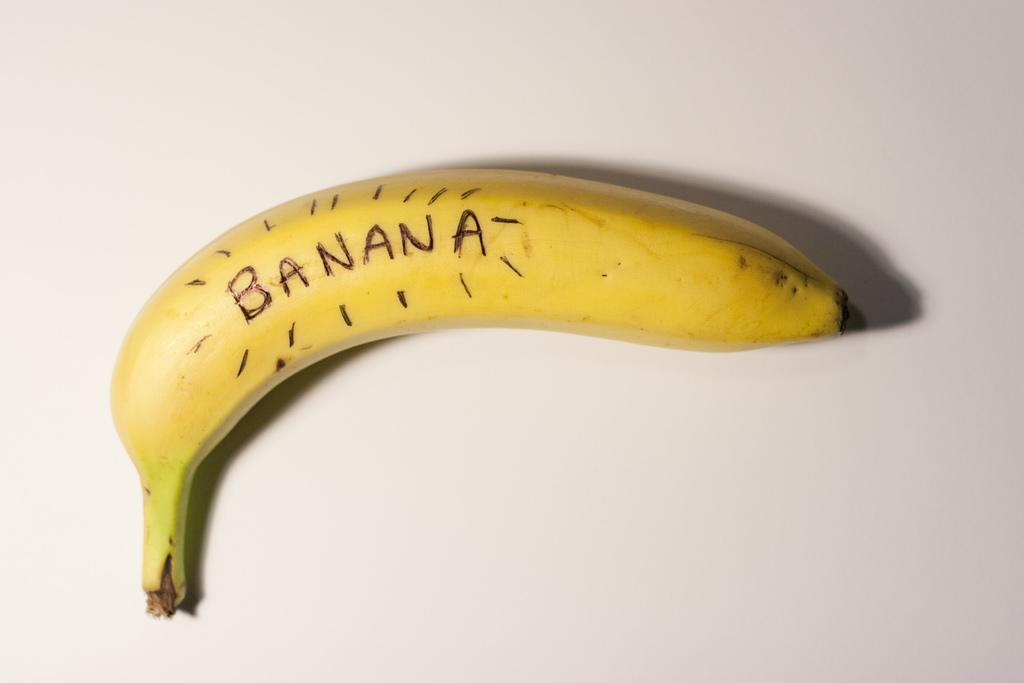Provide a one-sentence caption for the provided image. a banana with the word banana on it. 